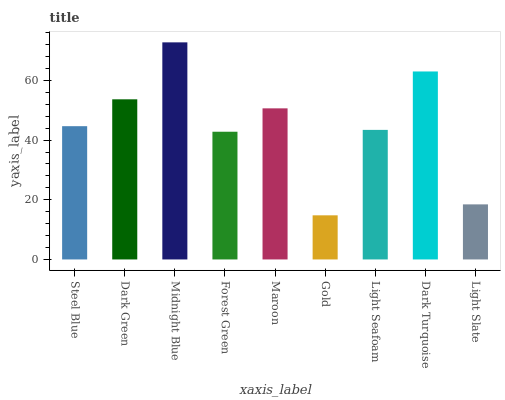Is Gold the minimum?
Answer yes or no. Yes. Is Midnight Blue the maximum?
Answer yes or no. Yes. Is Dark Green the minimum?
Answer yes or no. No. Is Dark Green the maximum?
Answer yes or no. No. Is Dark Green greater than Steel Blue?
Answer yes or no. Yes. Is Steel Blue less than Dark Green?
Answer yes or no. Yes. Is Steel Blue greater than Dark Green?
Answer yes or no. No. Is Dark Green less than Steel Blue?
Answer yes or no. No. Is Steel Blue the high median?
Answer yes or no. Yes. Is Steel Blue the low median?
Answer yes or no. Yes. Is Gold the high median?
Answer yes or no. No. Is Gold the low median?
Answer yes or no. No. 